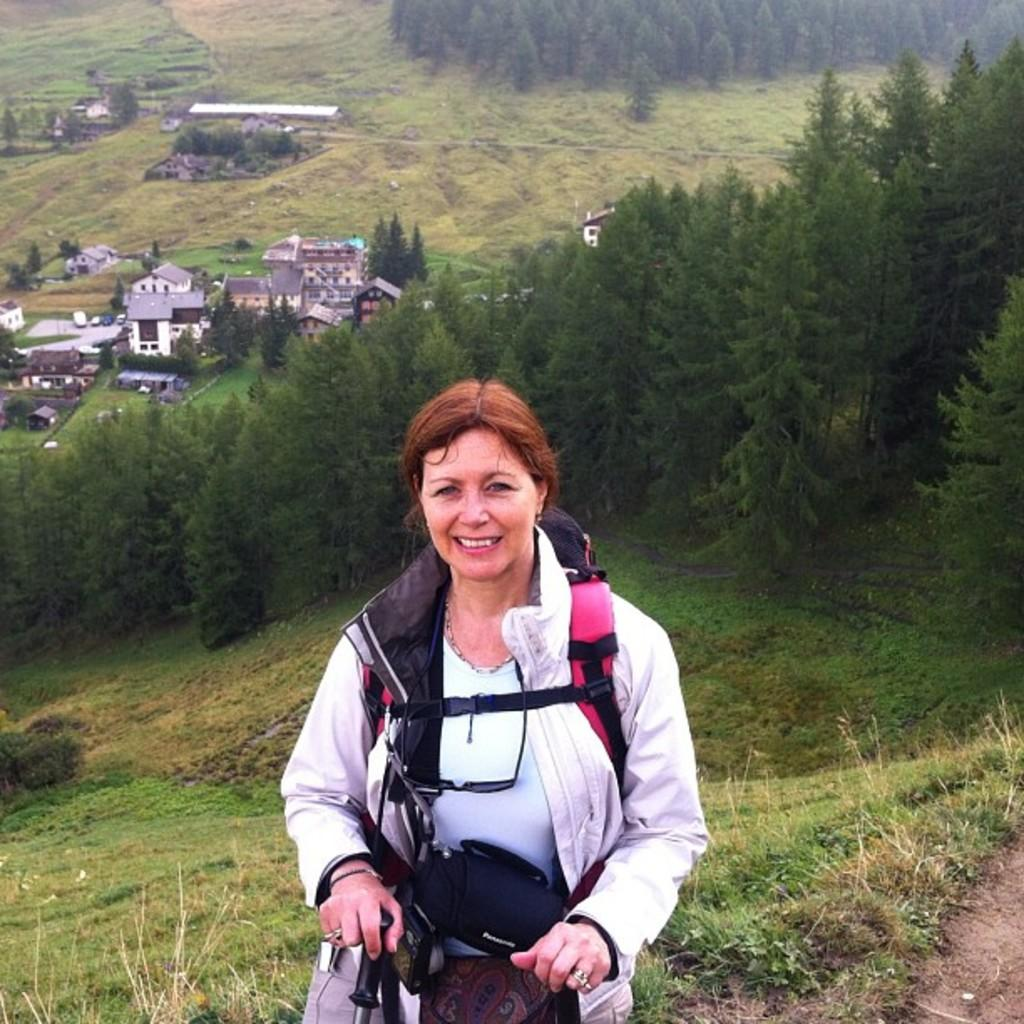What is the main subject in the foreground of the image? There is a woman standing in the foreground of the image. What type of natural environment is visible in the image? There is grass visible in the image. What can be seen in the background of the image? There are trees and houses in the background of the image. What grade does the woman receive for her performance in the image? There is no indication of a performance or grading system in the image, so it cannot be determined. 